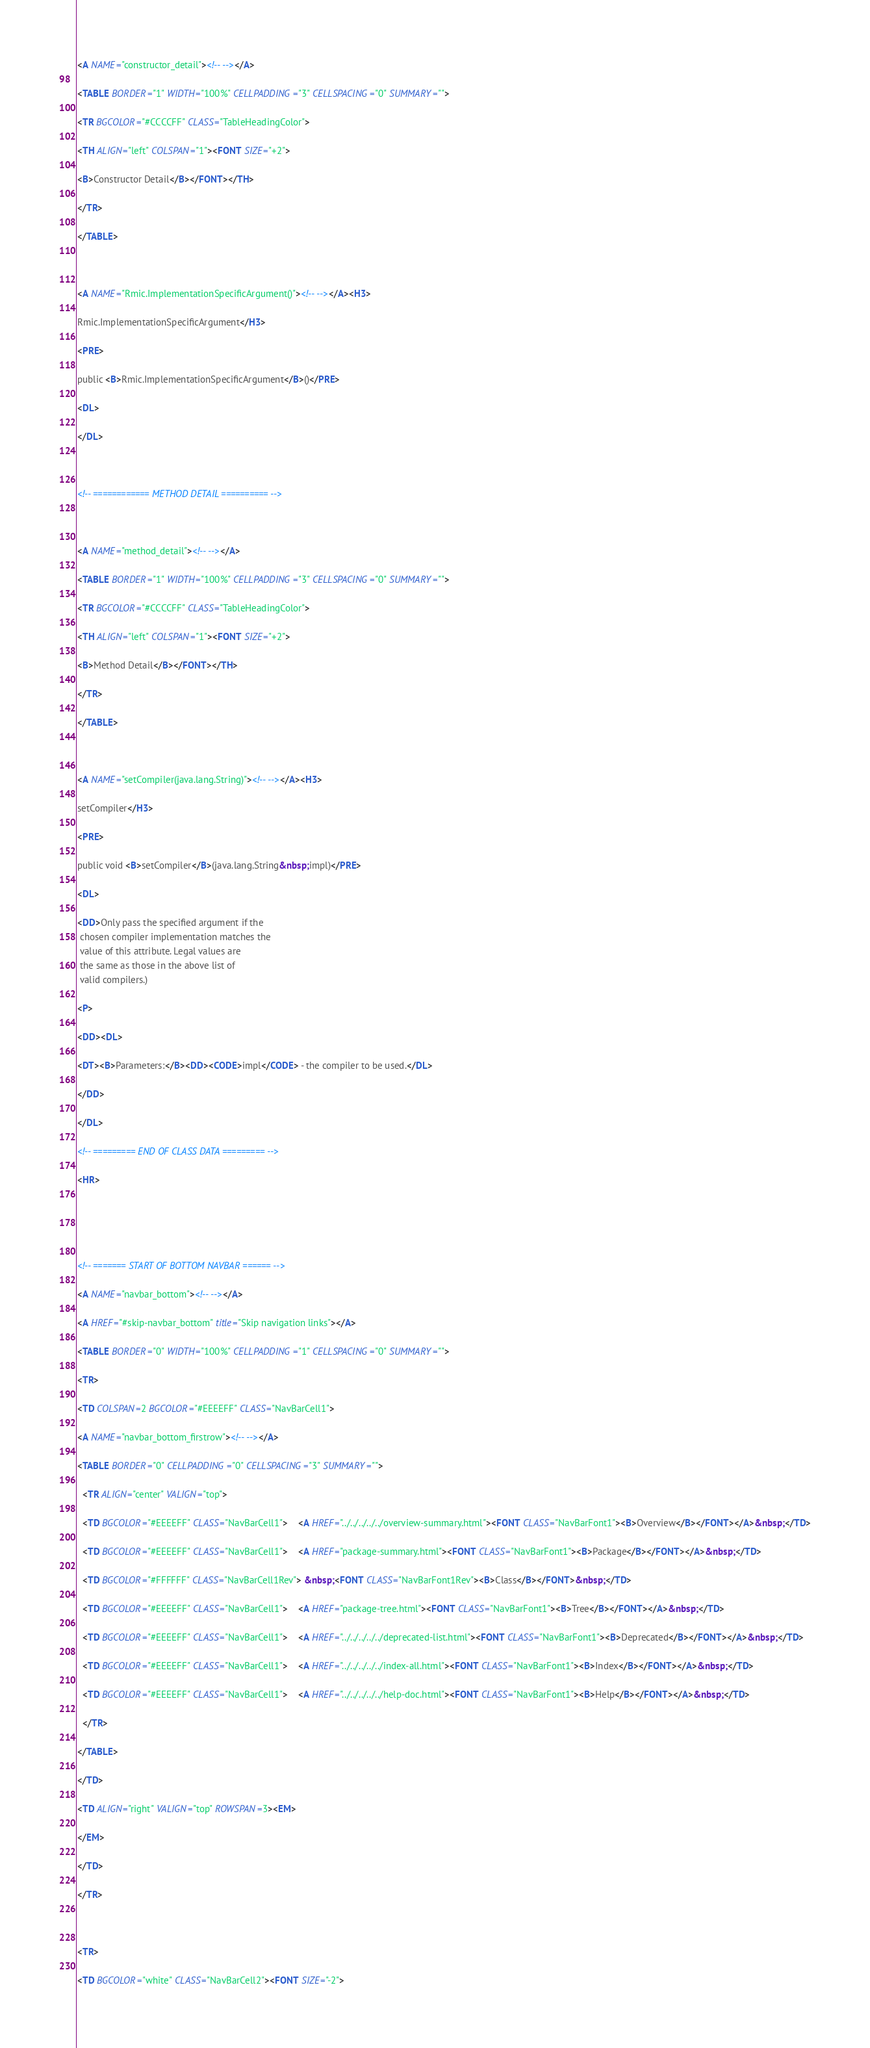Convert code to text. <code><loc_0><loc_0><loc_500><loc_500><_HTML_><A NAME="constructor_detail"><!-- --></A>
<TABLE BORDER="1" WIDTH="100%" CELLPADDING="3" CELLSPACING="0" SUMMARY="">
<TR BGCOLOR="#CCCCFF" CLASS="TableHeadingColor">
<TH ALIGN="left" COLSPAN="1"><FONT SIZE="+2">
<B>Constructor Detail</B></FONT></TH>
</TR>
</TABLE>

<A NAME="Rmic.ImplementationSpecificArgument()"><!-- --></A><H3>
Rmic.ImplementationSpecificArgument</H3>
<PRE>
public <B>Rmic.ImplementationSpecificArgument</B>()</PRE>
<DL>
</DL>

<!-- ============ METHOD DETAIL ========== -->

<A NAME="method_detail"><!-- --></A>
<TABLE BORDER="1" WIDTH="100%" CELLPADDING="3" CELLSPACING="0" SUMMARY="">
<TR BGCOLOR="#CCCCFF" CLASS="TableHeadingColor">
<TH ALIGN="left" COLSPAN="1"><FONT SIZE="+2">
<B>Method Detail</B></FONT></TH>
</TR>
</TABLE>

<A NAME="setCompiler(java.lang.String)"><!-- --></A><H3>
setCompiler</H3>
<PRE>
public void <B>setCompiler</B>(java.lang.String&nbsp;impl)</PRE>
<DL>
<DD>Only pass the specified argument if the
 chosen compiler implementation matches the
 value of this attribute. Legal values are
 the same as those in the above list of
 valid compilers.)
<P>
<DD><DL>
<DT><B>Parameters:</B><DD><CODE>impl</CODE> - the compiler to be used.</DL>
</DD>
</DL>
<!-- ========= END OF CLASS DATA ========= -->
<HR>


<!-- ======= START OF BOTTOM NAVBAR ====== -->
<A NAME="navbar_bottom"><!-- --></A>
<A HREF="#skip-navbar_bottom" title="Skip navigation links"></A>
<TABLE BORDER="0" WIDTH="100%" CELLPADDING="1" CELLSPACING="0" SUMMARY="">
<TR>
<TD COLSPAN=2 BGCOLOR="#EEEEFF" CLASS="NavBarCell1">
<A NAME="navbar_bottom_firstrow"><!-- --></A>
<TABLE BORDER="0" CELLPADDING="0" CELLSPACING="3" SUMMARY="">
  <TR ALIGN="center" VALIGN="top">
  <TD BGCOLOR="#EEEEFF" CLASS="NavBarCell1">    <A HREF="../../../../../overview-summary.html"><FONT CLASS="NavBarFont1"><B>Overview</B></FONT></A>&nbsp;</TD>
  <TD BGCOLOR="#EEEEFF" CLASS="NavBarCell1">    <A HREF="package-summary.html"><FONT CLASS="NavBarFont1"><B>Package</B></FONT></A>&nbsp;</TD>
  <TD BGCOLOR="#FFFFFF" CLASS="NavBarCell1Rev"> &nbsp;<FONT CLASS="NavBarFont1Rev"><B>Class</B></FONT>&nbsp;</TD>
  <TD BGCOLOR="#EEEEFF" CLASS="NavBarCell1">    <A HREF="package-tree.html"><FONT CLASS="NavBarFont1"><B>Tree</B></FONT></A>&nbsp;</TD>
  <TD BGCOLOR="#EEEEFF" CLASS="NavBarCell1">    <A HREF="../../../../../deprecated-list.html"><FONT CLASS="NavBarFont1"><B>Deprecated</B></FONT></A>&nbsp;</TD>
  <TD BGCOLOR="#EEEEFF" CLASS="NavBarCell1">    <A HREF="../../../../../index-all.html"><FONT CLASS="NavBarFont1"><B>Index</B></FONT></A>&nbsp;</TD>
  <TD BGCOLOR="#EEEEFF" CLASS="NavBarCell1">    <A HREF="../../../../../help-doc.html"><FONT CLASS="NavBarFont1"><B>Help</B></FONT></A>&nbsp;</TD>
  </TR>
</TABLE>
</TD>
<TD ALIGN="right" VALIGN="top" ROWSPAN=3><EM>
</EM>
</TD>
</TR>

<TR>
<TD BGCOLOR="white" CLASS="NavBarCell2"><FONT SIZE="-2"></code> 